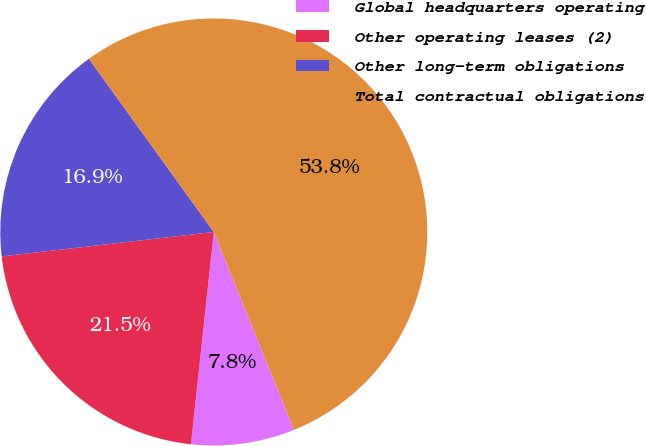Convert chart. <chart><loc_0><loc_0><loc_500><loc_500><pie_chart><fcel>Global headquarters operating<fcel>Other operating leases (2)<fcel>Other long-term obligations<fcel>Total contractual obligations<nl><fcel>7.84%<fcel>21.47%<fcel>16.88%<fcel>53.81%<nl></chart> 